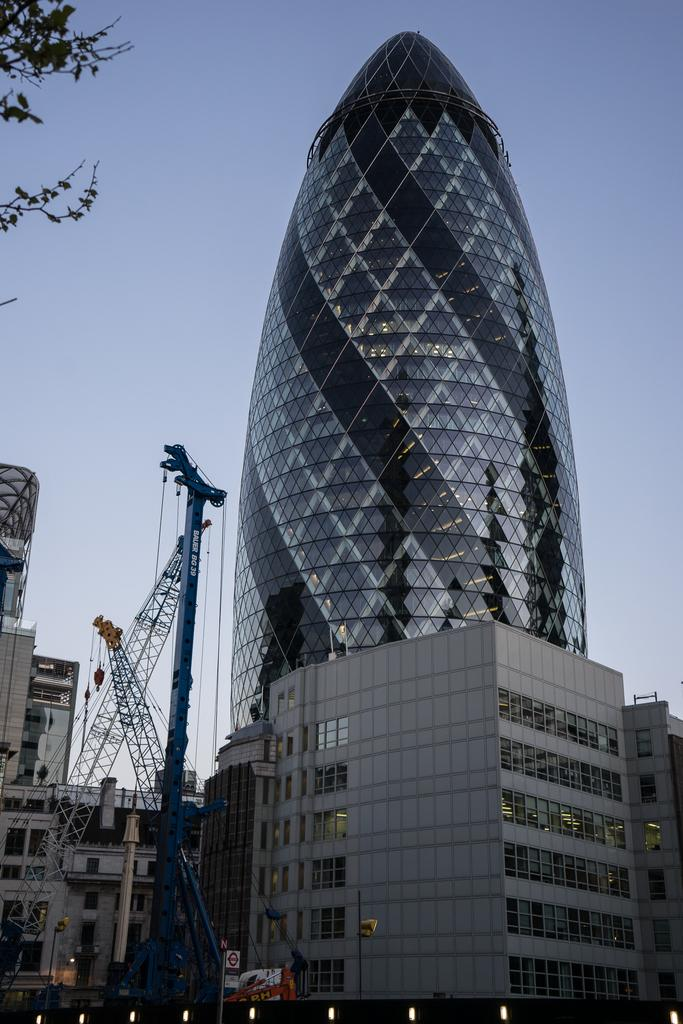What type of structures can be seen in the image? There are buildings in the image. What equipment is present in the image? There are cranes in the image. What can be used for illumination in the image? There are lights in the image. What else is present in the image besides buildings and cranes? There are objects and branches with leaves in the image. What is visible in the background of the image? The sky is visible in the background of the image. What route should be taken to reach the mine in the image? There is no mine present in the image, so it is not possible to determine a route to reach it. 